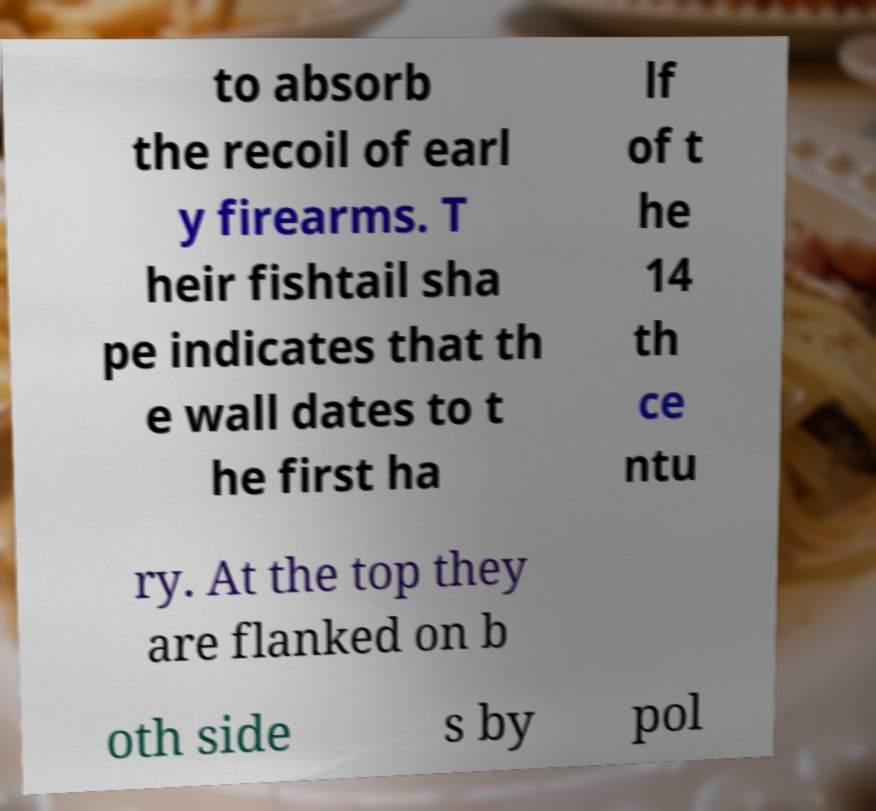I need the written content from this picture converted into text. Can you do that? to absorb the recoil of earl y firearms. T heir fishtail sha pe indicates that th e wall dates to t he first ha lf of t he 14 th ce ntu ry. At the top they are flanked on b oth side s by pol 